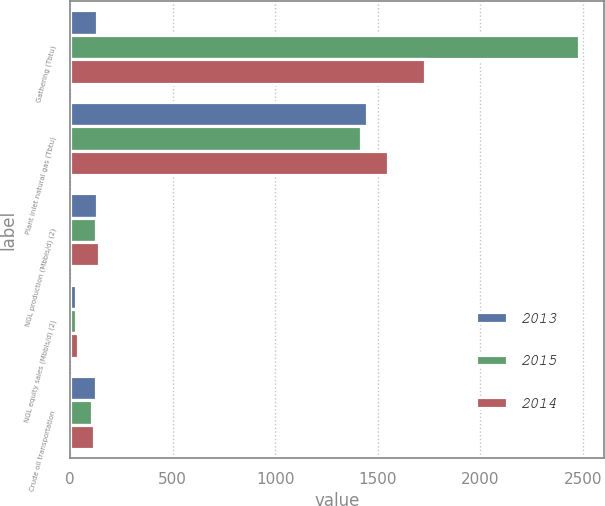Convert chart. <chart><loc_0><loc_0><loc_500><loc_500><stacked_bar_chart><ecel><fcel>Gathering (Tbtu)<fcel>Plant inlet natural gas (Tbtu)<fcel>NGL production (Mbbls/d) (2)<fcel>NGL equity sales (Mbbls/d) (2)<fcel>Crude oil transportation<nl><fcel>2013<fcel>129<fcel>1448<fcel>130<fcel>31<fcel>126<nl><fcel>2015<fcel>2482<fcel>1419<fcel>128<fcel>27<fcel>105<nl><fcel>2014<fcel>1731<fcel>1549<fcel>143<fcel>40<fcel>117<nl></chart> 